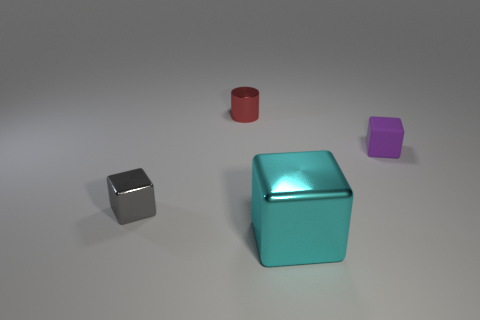Add 3 purple rubber cubes. How many objects exist? 7 Subtract all blue cubes. Subtract all tiny red shiny objects. How many objects are left? 3 Add 3 red cylinders. How many red cylinders are left? 4 Add 1 big metallic things. How many big metallic things exist? 2 Subtract 0 green cylinders. How many objects are left? 4 Subtract all cylinders. How many objects are left? 3 Subtract all yellow cubes. Subtract all red balls. How many cubes are left? 3 